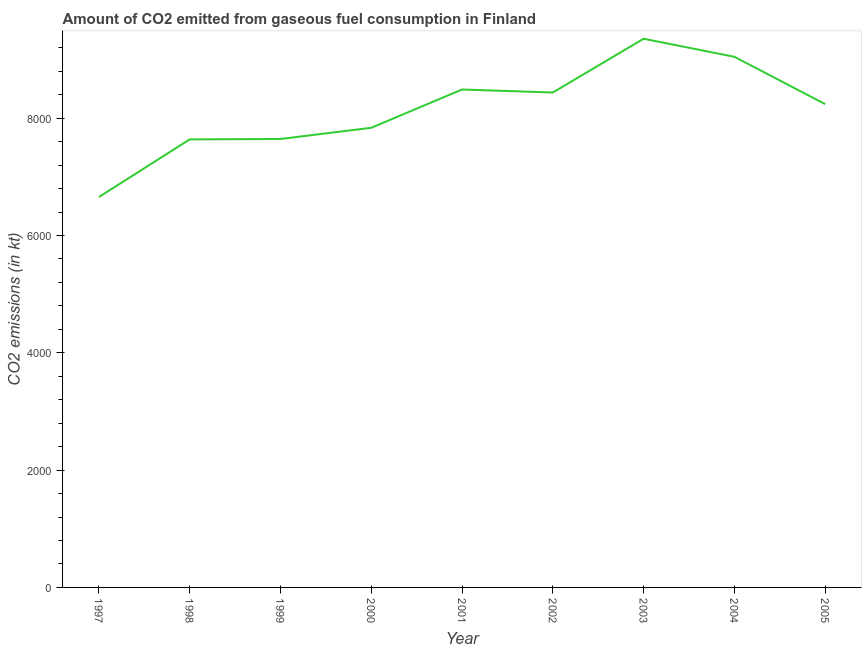What is the co2 emissions from gaseous fuel consumption in 2001?
Keep it short and to the point. 8489.1. Across all years, what is the maximum co2 emissions from gaseous fuel consumption?
Your answer should be compact. 9354.52. Across all years, what is the minimum co2 emissions from gaseous fuel consumption?
Ensure brevity in your answer.  6655.6. In which year was the co2 emissions from gaseous fuel consumption maximum?
Keep it short and to the point. 2003. What is the sum of the co2 emissions from gaseous fuel consumption?
Provide a succinct answer. 7.33e+04. What is the difference between the co2 emissions from gaseous fuel consumption in 2002 and 2003?
Make the answer very short. -916.75. What is the average co2 emissions from gaseous fuel consumption per year?
Ensure brevity in your answer.  8149.3. What is the median co2 emissions from gaseous fuel consumption?
Provide a short and direct response. 8239.75. What is the ratio of the co2 emissions from gaseous fuel consumption in 2004 to that in 2005?
Your answer should be very brief. 1.1. Is the difference between the co2 emissions from gaseous fuel consumption in 2000 and 2001 greater than the difference between any two years?
Provide a short and direct response. No. What is the difference between the highest and the second highest co2 emissions from gaseous fuel consumption?
Offer a very short reply. 308.03. Is the sum of the co2 emissions from gaseous fuel consumption in 1997 and 2003 greater than the maximum co2 emissions from gaseous fuel consumption across all years?
Your answer should be compact. Yes. What is the difference between the highest and the lowest co2 emissions from gaseous fuel consumption?
Provide a succinct answer. 2698.91. How many lines are there?
Ensure brevity in your answer.  1. What is the difference between two consecutive major ticks on the Y-axis?
Offer a terse response. 2000. Does the graph contain grids?
Make the answer very short. No. What is the title of the graph?
Provide a succinct answer. Amount of CO2 emitted from gaseous fuel consumption in Finland. What is the label or title of the X-axis?
Provide a short and direct response. Year. What is the label or title of the Y-axis?
Give a very brief answer. CO2 emissions (in kt). What is the CO2 emissions (in kt) of 1997?
Ensure brevity in your answer.  6655.6. What is the CO2 emissions (in kt) in 1998?
Your response must be concise. 7638.36. What is the CO2 emissions (in kt) in 1999?
Make the answer very short. 7645.69. What is the CO2 emissions (in kt) of 2000?
Your answer should be compact. 7836.38. What is the CO2 emissions (in kt) in 2001?
Ensure brevity in your answer.  8489.1. What is the CO2 emissions (in kt) in 2002?
Give a very brief answer. 8437.77. What is the CO2 emissions (in kt) of 2003?
Keep it short and to the point. 9354.52. What is the CO2 emissions (in kt) in 2004?
Offer a terse response. 9046.49. What is the CO2 emissions (in kt) in 2005?
Provide a succinct answer. 8239.75. What is the difference between the CO2 emissions (in kt) in 1997 and 1998?
Your response must be concise. -982.76. What is the difference between the CO2 emissions (in kt) in 1997 and 1999?
Offer a very short reply. -990.09. What is the difference between the CO2 emissions (in kt) in 1997 and 2000?
Provide a succinct answer. -1180.77. What is the difference between the CO2 emissions (in kt) in 1997 and 2001?
Make the answer very short. -1833.5. What is the difference between the CO2 emissions (in kt) in 1997 and 2002?
Your response must be concise. -1782.16. What is the difference between the CO2 emissions (in kt) in 1997 and 2003?
Provide a succinct answer. -2698.91. What is the difference between the CO2 emissions (in kt) in 1997 and 2004?
Give a very brief answer. -2390.88. What is the difference between the CO2 emissions (in kt) in 1997 and 2005?
Offer a very short reply. -1584.14. What is the difference between the CO2 emissions (in kt) in 1998 and 1999?
Make the answer very short. -7.33. What is the difference between the CO2 emissions (in kt) in 1998 and 2000?
Give a very brief answer. -198.02. What is the difference between the CO2 emissions (in kt) in 1998 and 2001?
Ensure brevity in your answer.  -850.74. What is the difference between the CO2 emissions (in kt) in 1998 and 2002?
Offer a terse response. -799.41. What is the difference between the CO2 emissions (in kt) in 1998 and 2003?
Provide a short and direct response. -1716.16. What is the difference between the CO2 emissions (in kt) in 1998 and 2004?
Your answer should be very brief. -1408.13. What is the difference between the CO2 emissions (in kt) in 1998 and 2005?
Keep it short and to the point. -601.39. What is the difference between the CO2 emissions (in kt) in 1999 and 2000?
Offer a terse response. -190.68. What is the difference between the CO2 emissions (in kt) in 1999 and 2001?
Offer a very short reply. -843.41. What is the difference between the CO2 emissions (in kt) in 1999 and 2002?
Offer a terse response. -792.07. What is the difference between the CO2 emissions (in kt) in 1999 and 2003?
Your answer should be very brief. -1708.82. What is the difference between the CO2 emissions (in kt) in 1999 and 2004?
Keep it short and to the point. -1400.79. What is the difference between the CO2 emissions (in kt) in 1999 and 2005?
Your response must be concise. -594.05. What is the difference between the CO2 emissions (in kt) in 2000 and 2001?
Keep it short and to the point. -652.73. What is the difference between the CO2 emissions (in kt) in 2000 and 2002?
Offer a terse response. -601.39. What is the difference between the CO2 emissions (in kt) in 2000 and 2003?
Provide a short and direct response. -1518.14. What is the difference between the CO2 emissions (in kt) in 2000 and 2004?
Provide a succinct answer. -1210.11. What is the difference between the CO2 emissions (in kt) in 2000 and 2005?
Offer a very short reply. -403.37. What is the difference between the CO2 emissions (in kt) in 2001 and 2002?
Give a very brief answer. 51.34. What is the difference between the CO2 emissions (in kt) in 2001 and 2003?
Your answer should be compact. -865.41. What is the difference between the CO2 emissions (in kt) in 2001 and 2004?
Your answer should be compact. -557.38. What is the difference between the CO2 emissions (in kt) in 2001 and 2005?
Your answer should be compact. 249.36. What is the difference between the CO2 emissions (in kt) in 2002 and 2003?
Provide a short and direct response. -916.75. What is the difference between the CO2 emissions (in kt) in 2002 and 2004?
Offer a terse response. -608.72. What is the difference between the CO2 emissions (in kt) in 2002 and 2005?
Keep it short and to the point. 198.02. What is the difference between the CO2 emissions (in kt) in 2003 and 2004?
Offer a very short reply. 308.03. What is the difference between the CO2 emissions (in kt) in 2003 and 2005?
Make the answer very short. 1114.77. What is the difference between the CO2 emissions (in kt) in 2004 and 2005?
Offer a very short reply. 806.74. What is the ratio of the CO2 emissions (in kt) in 1997 to that in 1998?
Make the answer very short. 0.87. What is the ratio of the CO2 emissions (in kt) in 1997 to that in 1999?
Your answer should be very brief. 0.87. What is the ratio of the CO2 emissions (in kt) in 1997 to that in 2000?
Your answer should be compact. 0.85. What is the ratio of the CO2 emissions (in kt) in 1997 to that in 2001?
Make the answer very short. 0.78. What is the ratio of the CO2 emissions (in kt) in 1997 to that in 2002?
Your answer should be very brief. 0.79. What is the ratio of the CO2 emissions (in kt) in 1997 to that in 2003?
Offer a terse response. 0.71. What is the ratio of the CO2 emissions (in kt) in 1997 to that in 2004?
Make the answer very short. 0.74. What is the ratio of the CO2 emissions (in kt) in 1997 to that in 2005?
Your response must be concise. 0.81. What is the ratio of the CO2 emissions (in kt) in 1998 to that in 1999?
Make the answer very short. 1. What is the ratio of the CO2 emissions (in kt) in 1998 to that in 2001?
Give a very brief answer. 0.9. What is the ratio of the CO2 emissions (in kt) in 1998 to that in 2002?
Offer a very short reply. 0.91. What is the ratio of the CO2 emissions (in kt) in 1998 to that in 2003?
Give a very brief answer. 0.82. What is the ratio of the CO2 emissions (in kt) in 1998 to that in 2004?
Your answer should be compact. 0.84. What is the ratio of the CO2 emissions (in kt) in 1998 to that in 2005?
Provide a short and direct response. 0.93. What is the ratio of the CO2 emissions (in kt) in 1999 to that in 2001?
Keep it short and to the point. 0.9. What is the ratio of the CO2 emissions (in kt) in 1999 to that in 2002?
Provide a short and direct response. 0.91. What is the ratio of the CO2 emissions (in kt) in 1999 to that in 2003?
Offer a terse response. 0.82. What is the ratio of the CO2 emissions (in kt) in 1999 to that in 2004?
Give a very brief answer. 0.84. What is the ratio of the CO2 emissions (in kt) in 1999 to that in 2005?
Give a very brief answer. 0.93. What is the ratio of the CO2 emissions (in kt) in 2000 to that in 2001?
Give a very brief answer. 0.92. What is the ratio of the CO2 emissions (in kt) in 2000 to that in 2002?
Give a very brief answer. 0.93. What is the ratio of the CO2 emissions (in kt) in 2000 to that in 2003?
Your response must be concise. 0.84. What is the ratio of the CO2 emissions (in kt) in 2000 to that in 2004?
Offer a very short reply. 0.87. What is the ratio of the CO2 emissions (in kt) in 2000 to that in 2005?
Make the answer very short. 0.95. What is the ratio of the CO2 emissions (in kt) in 2001 to that in 2003?
Ensure brevity in your answer.  0.91. What is the ratio of the CO2 emissions (in kt) in 2001 to that in 2004?
Offer a very short reply. 0.94. What is the ratio of the CO2 emissions (in kt) in 2002 to that in 2003?
Make the answer very short. 0.9. What is the ratio of the CO2 emissions (in kt) in 2002 to that in 2004?
Offer a terse response. 0.93. What is the ratio of the CO2 emissions (in kt) in 2003 to that in 2004?
Provide a succinct answer. 1.03. What is the ratio of the CO2 emissions (in kt) in 2003 to that in 2005?
Provide a succinct answer. 1.14. What is the ratio of the CO2 emissions (in kt) in 2004 to that in 2005?
Provide a succinct answer. 1.1. 